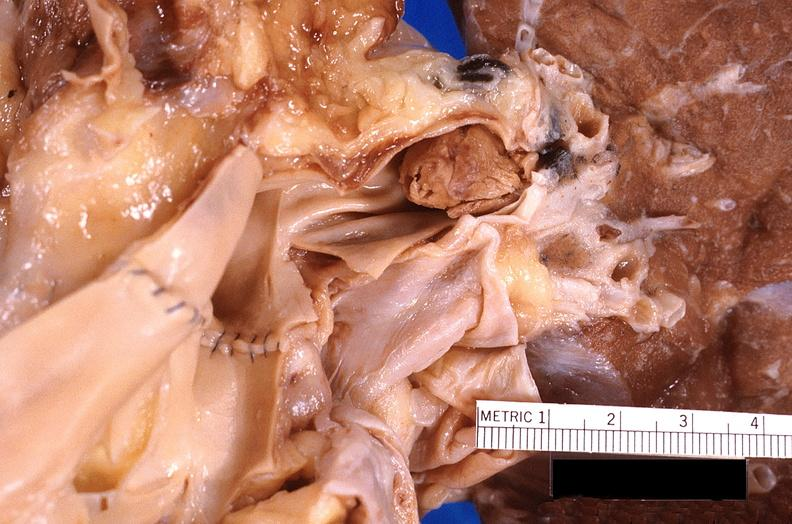s respiratory present?
Answer the question using a single word or phrase. Yes 